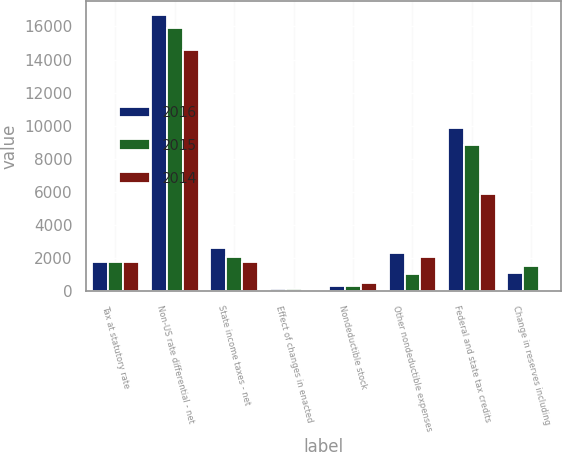Convert chart. <chart><loc_0><loc_0><loc_500><loc_500><stacked_bar_chart><ecel><fcel>Tax at statutory rate<fcel>Non-US rate differential - net<fcel>State income taxes - net<fcel>Effect of changes in enacted<fcel>Nondeductible stock<fcel>Other nondeductible expenses<fcel>Federal and state tax credits<fcel>Change in reserves including<nl><fcel>2016<fcel>1787<fcel>16718<fcel>2640<fcel>111<fcel>296<fcel>2307<fcel>9840<fcel>1105<nl><fcel>2015<fcel>1787<fcel>15931<fcel>2094<fcel>153<fcel>338<fcel>1039<fcel>8837<fcel>1522<nl><fcel>2014<fcel>1787<fcel>14590<fcel>1787<fcel>44<fcel>483<fcel>2063<fcel>5865<fcel>7<nl></chart> 